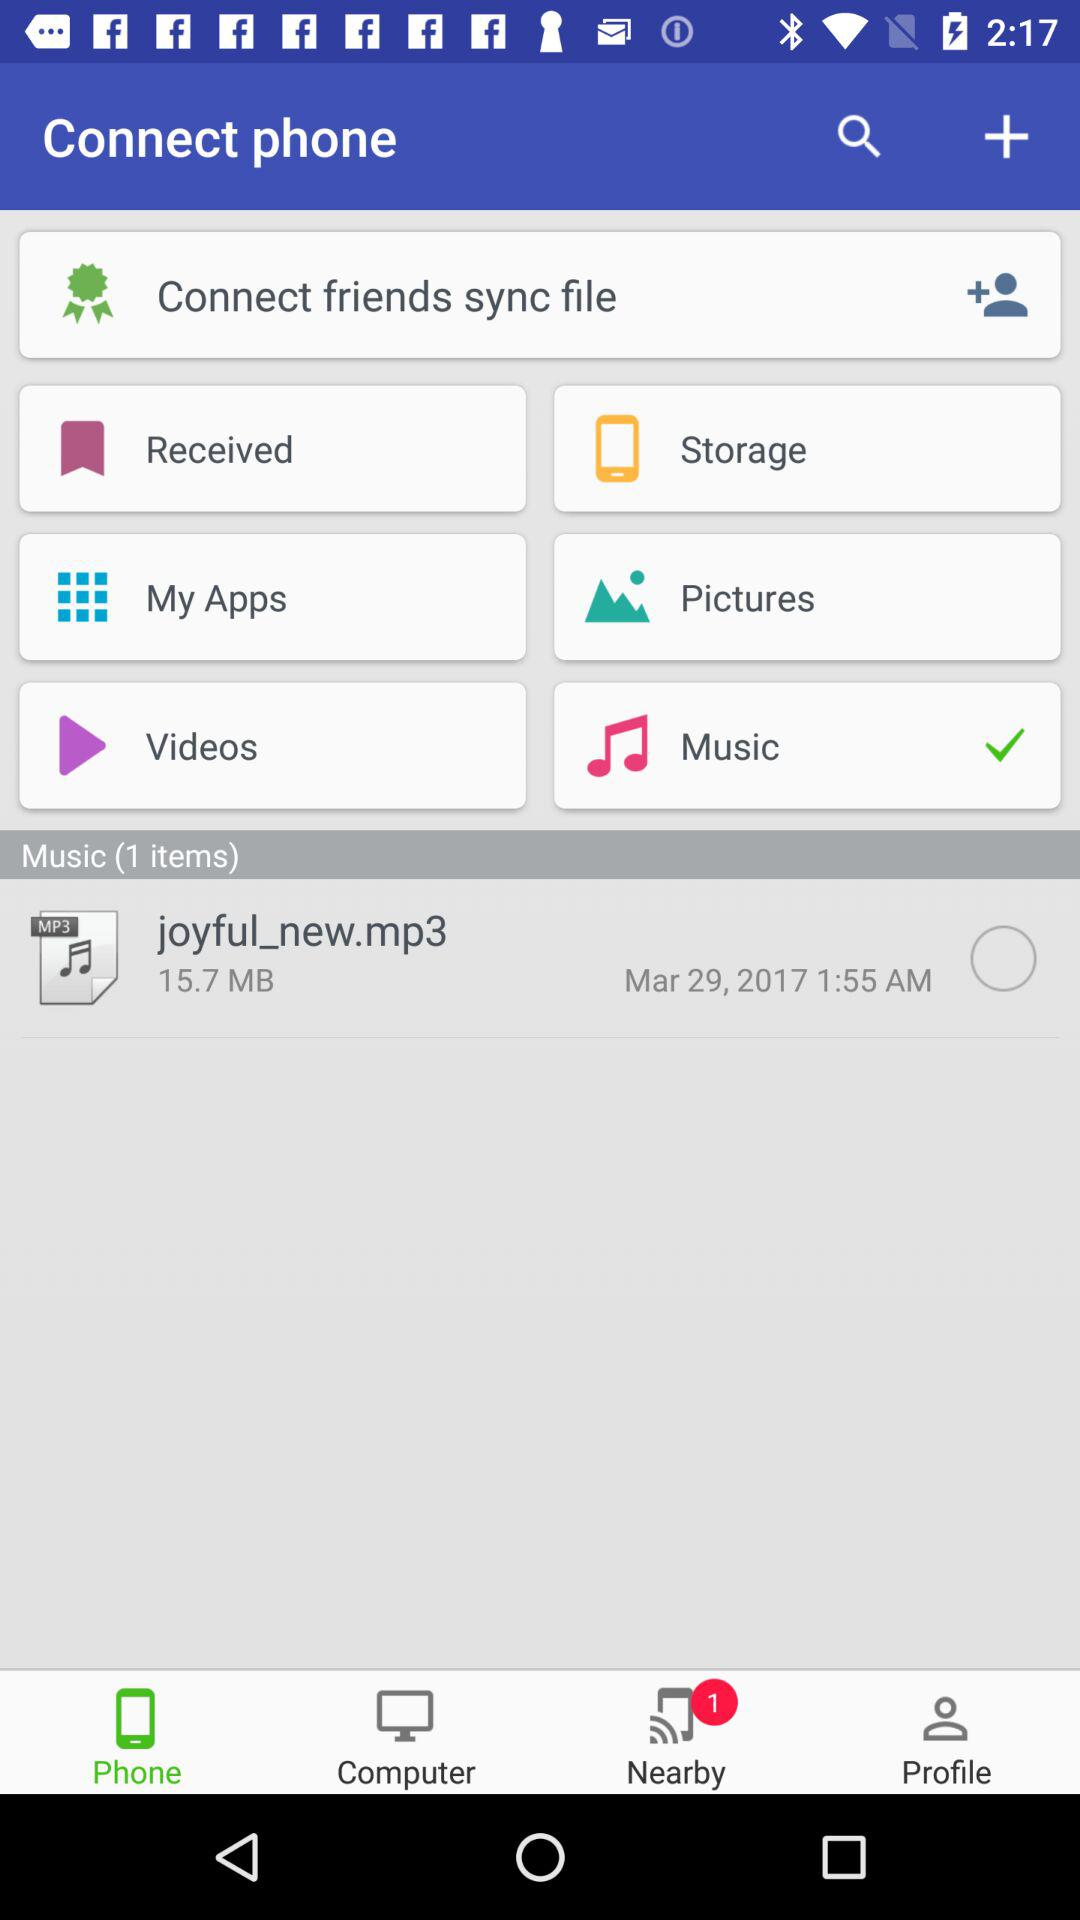How many items are in the music library?
Answer the question using a single word or phrase. 1 